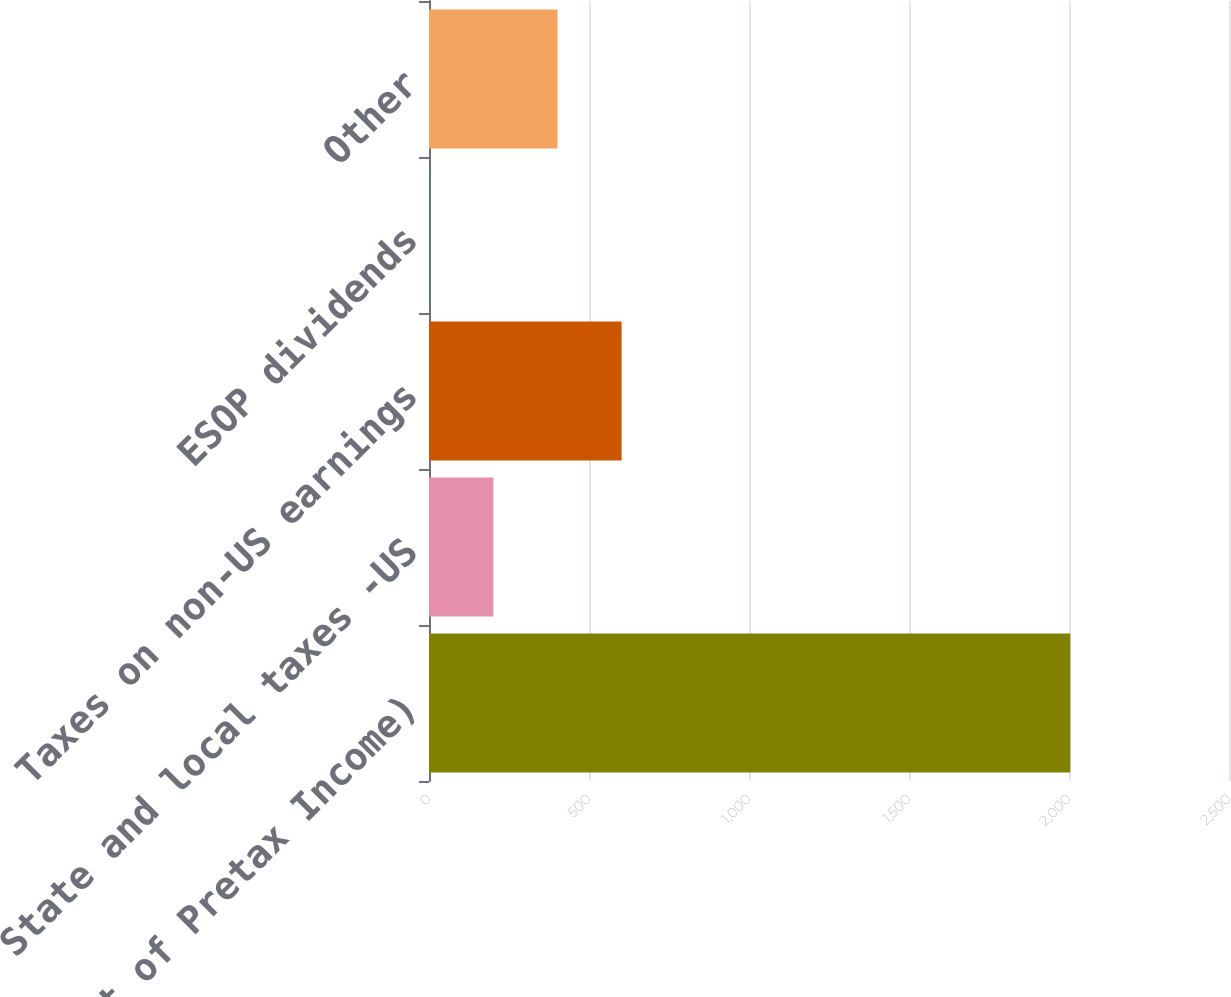<chart> <loc_0><loc_0><loc_500><loc_500><bar_chart><fcel>(Percent of Pretax Income)<fcel>State and local taxes -US<fcel>Taxes on non-US earnings<fcel>ESOP dividends<fcel>Other<nl><fcel>2004<fcel>201.37<fcel>601.95<fcel>1.08<fcel>401.66<nl></chart> 